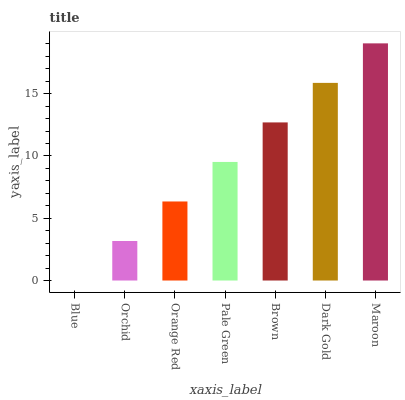Is Orchid the minimum?
Answer yes or no. No. Is Orchid the maximum?
Answer yes or no. No. Is Orchid greater than Blue?
Answer yes or no. Yes. Is Blue less than Orchid?
Answer yes or no. Yes. Is Blue greater than Orchid?
Answer yes or no. No. Is Orchid less than Blue?
Answer yes or no. No. Is Pale Green the high median?
Answer yes or no. Yes. Is Pale Green the low median?
Answer yes or no. Yes. Is Brown the high median?
Answer yes or no. No. Is Orange Red the low median?
Answer yes or no. No. 